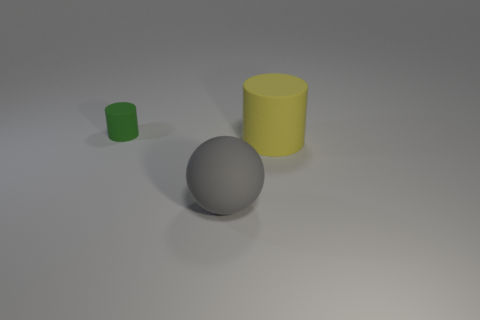Add 1 tiny brown matte spheres. How many objects exist? 4 Subtract all balls. How many objects are left? 2 Subtract 0 green spheres. How many objects are left? 3 Subtract all small green matte things. Subtract all large gray spheres. How many objects are left? 1 Add 3 large rubber objects. How many large rubber objects are left? 5 Add 3 large yellow blocks. How many large yellow blocks exist? 3 